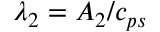<formula> <loc_0><loc_0><loc_500><loc_500>\lambda _ { 2 } = A _ { 2 } / c _ { p s }</formula> 